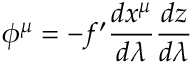<formula> <loc_0><loc_0><loc_500><loc_500>\phi ^ { \mu } = - f ^ { \prime } \frac { d x ^ { \mu } } { d \lambda } \frac { d z } { d \lambda }</formula> 